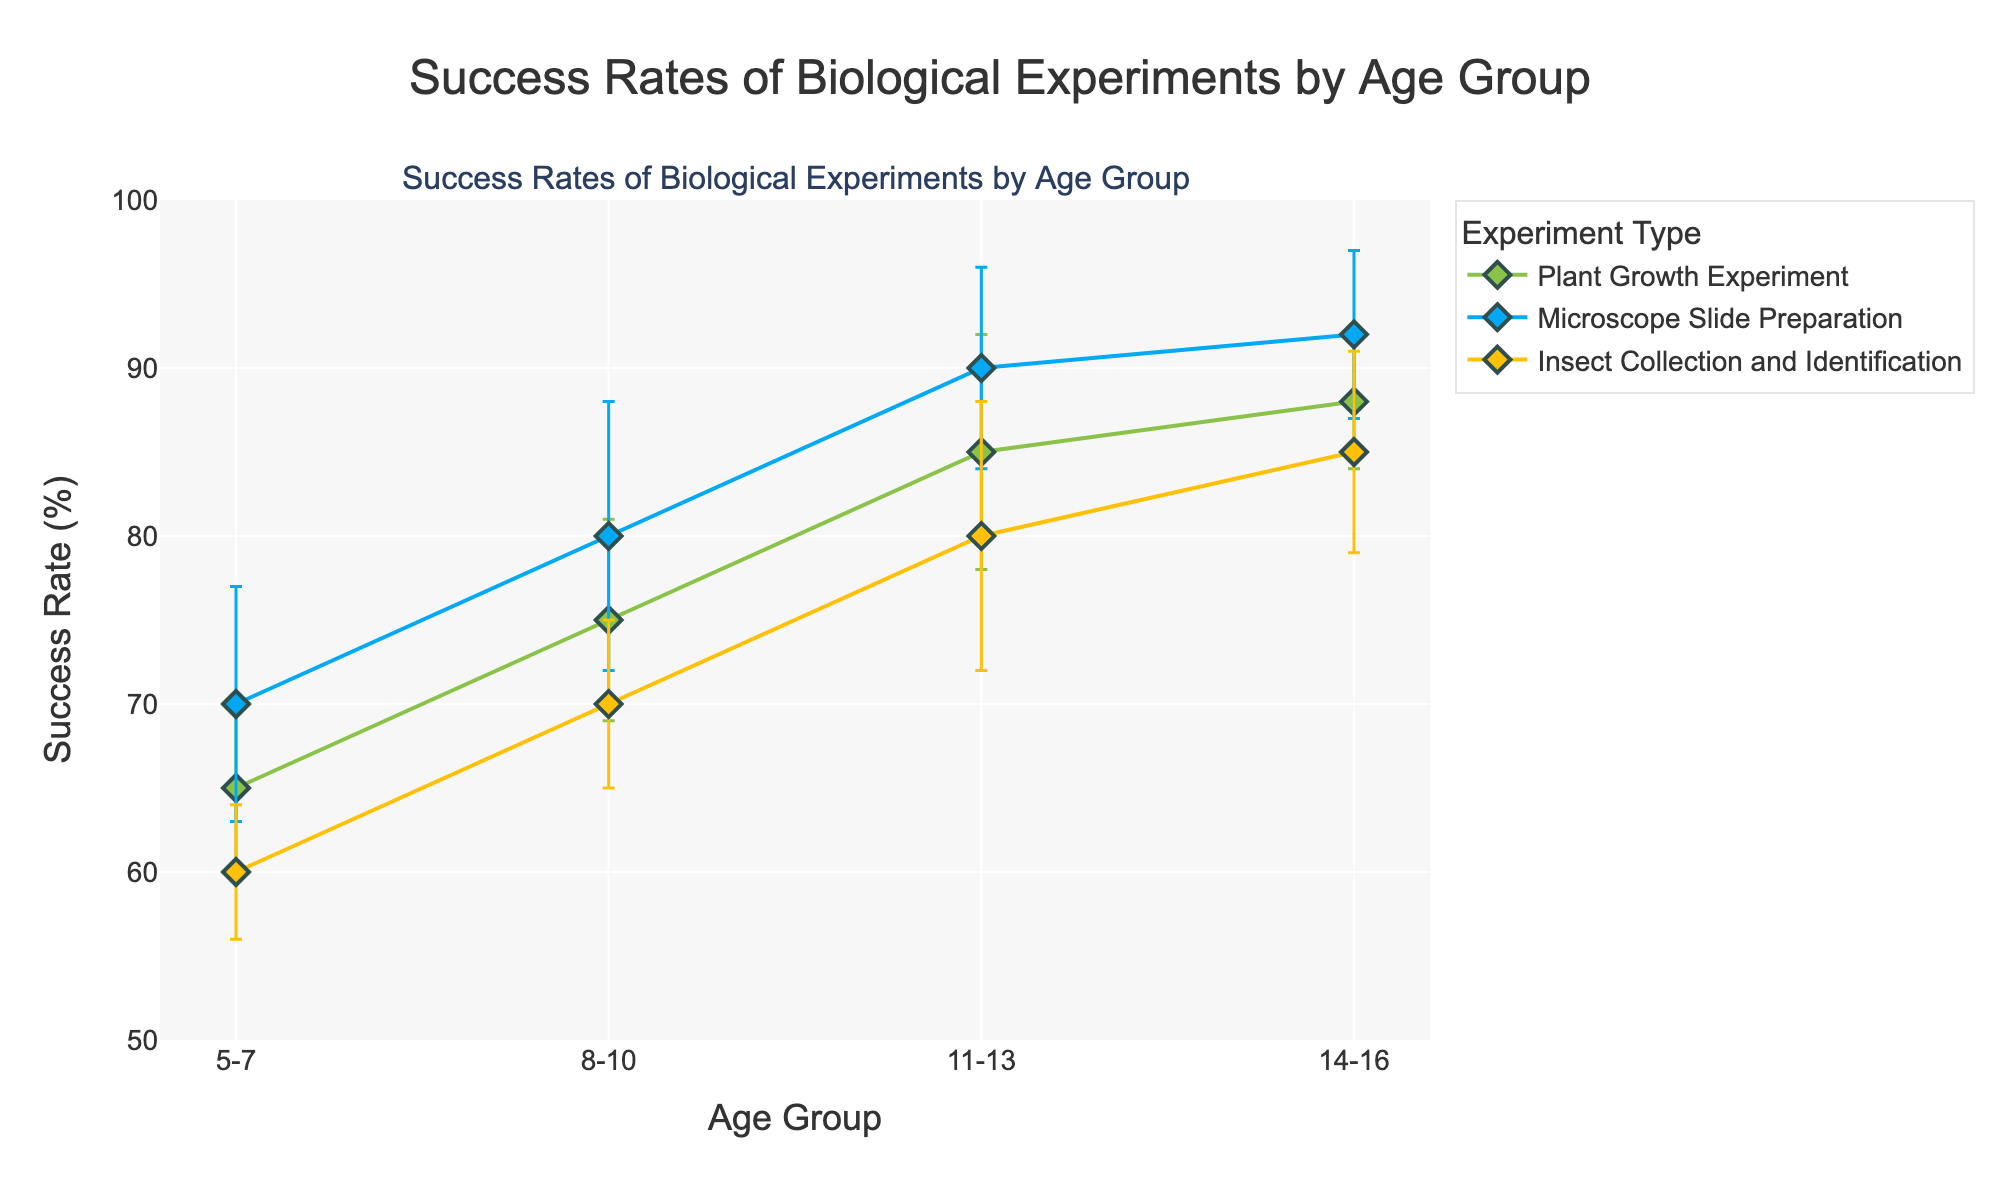Which experiment had the smallest standard deviation in success rates for the 5-7 age group? For the 5-7 age group, the standard deviations are 5 for Plant Growth Experiment, 7 for Microscope Slide Preparation, and 4 for Insect Collection and Identification. The smallest is 4 for Insect Collection and Identification.
Answer: Insect Collection and Identification How does the success rate of the Insect Collection and Identification experiment for the 14-16 age group compare to the 8-10 age group? The success rates are 85% for 14-16 and 70% for 8-10. The rate for 14-16 is greater by 15%.
Answer: 14-16 is greater by 15% What's the average success rate across all experiments for the 11-13 age group? The success rates are 85, 90, and 80. The average is (85 + 90 + 80) / 3 = 85%.
Answer: 85% In which age group did the Plant Growth Experiment show the highest improvement compared to the previous group? The success rates are 65%, 75%, 85%, and 88% for age groups 5-7, 8-10, 11-13, and 14-16 respectively. The highest improvement is 85% - 75% = 10% from 8-10 to 11-13.
Answer: 8-10 to 11-13 with 10% Is there any age group where the standard deviations for all experiments are equal? Observing the standard deviations for each experiment per age group, there is no age group where all standard deviations are equal.
Answer: No Identify the experiment with the least variation in success rate across all age groups. Variation is measured by standard deviation. Plant Growth Experiment has standard deviations of 5, 6, 7, and 4, which sums to 22. Microscope Slide Preparation has 7, 8, 6, and 5, summing to 26. Insect Collection and Identification has 4, 5, 8, and 6, summing to 23. Plant Growth has the least variation.
Answer: Plant Growth Experiment 